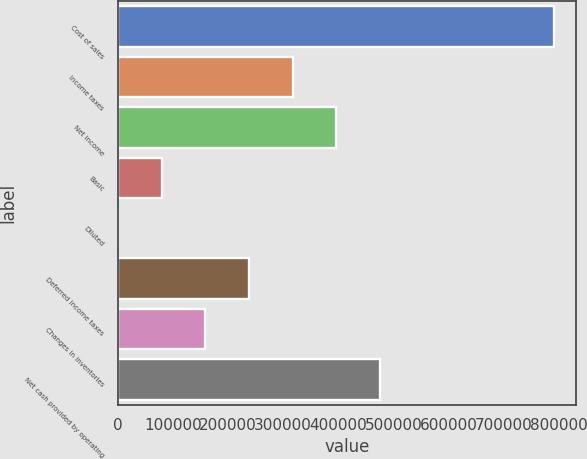<chart> <loc_0><loc_0><loc_500><loc_500><bar_chart><fcel>Cost of sales<fcel>Income taxes<fcel>Net income<fcel>Basic<fcel>Diluted<fcel>Deferred income taxes<fcel>Changes in inventories<fcel>Net cash provided by operating<nl><fcel>792470<fcel>316989<fcel>396236<fcel>79248.7<fcel>1.87<fcel>237742<fcel>158495<fcel>475483<nl></chart> 